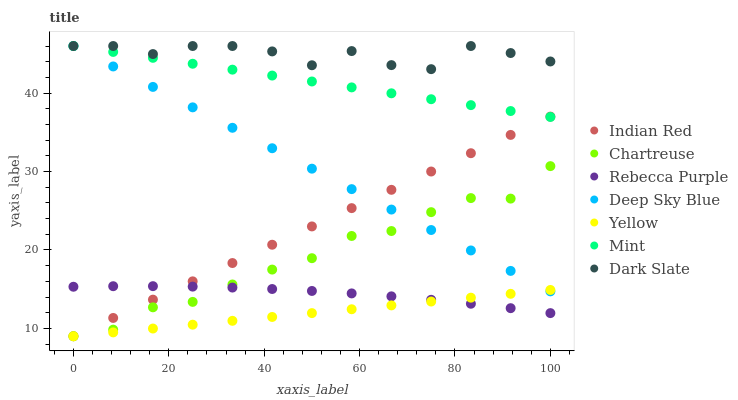Does Yellow have the minimum area under the curve?
Answer yes or no. Yes. Does Dark Slate have the maximum area under the curve?
Answer yes or no. Yes. Does Dark Slate have the minimum area under the curve?
Answer yes or no. No. Does Yellow have the maximum area under the curve?
Answer yes or no. No. Is Yellow the smoothest?
Answer yes or no. Yes. Is Dark Slate the roughest?
Answer yes or no. Yes. Is Dark Slate the smoothest?
Answer yes or no. No. Is Yellow the roughest?
Answer yes or no. No. Does Indian Red have the lowest value?
Answer yes or no. Yes. Does Dark Slate have the lowest value?
Answer yes or no. No. Does Mint have the highest value?
Answer yes or no. Yes. Does Yellow have the highest value?
Answer yes or no. No. Is Yellow less than Dark Slate?
Answer yes or no. Yes. Is Mint greater than Yellow?
Answer yes or no. Yes. Does Indian Red intersect Yellow?
Answer yes or no. Yes. Is Indian Red less than Yellow?
Answer yes or no. No. Is Indian Red greater than Yellow?
Answer yes or no. No. Does Yellow intersect Dark Slate?
Answer yes or no. No. 